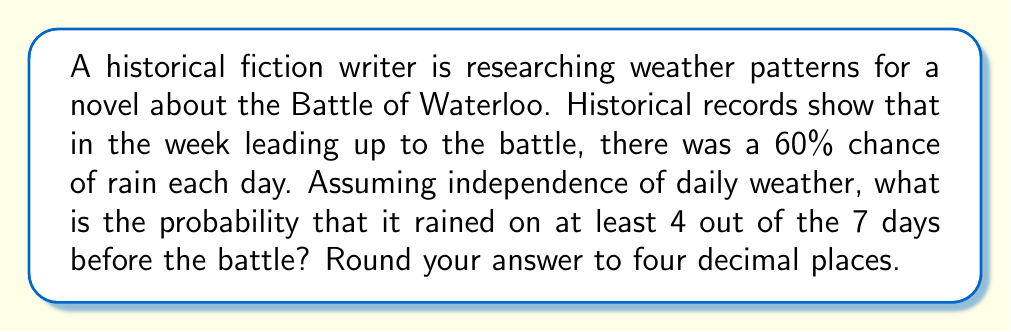What is the answer to this math problem? To solve this problem, we'll use the binomial probability distribution and the complement rule.

Let $X$ be the number of rainy days in the week.
$n = 7$ (number of days)
$p = 0.60$ (probability of rain each day)

We need to find $P(X \geq 4)$, which is equivalent to $1 - P(X \leq 3)$

Using the complement rule:
$P(X \geq 4) = 1 - P(X \leq 3)$

$P(X \leq 3)$ can be calculated as the sum of probabilities for 0, 1, 2, and 3 rainy days:

$P(X \leq 3) = P(X=0) + P(X=1) + P(X=2) + P(X=3)$

The probability for each case can be calculated using the binomial probability formula:

$P(X=k) = \binom{n}{k} p^k (1-p)^{n-k}$

Calculating each term:

$P(X=0) = \binom{7}{0} 0.60^0 (1-0.60)^7 = 0.0016384$

$P(X=1) = \binom{7}{1} 0.60^1 (1-0.60)^6 = 0.0172032$

$P(X=2) = \binom{7}{2} 0.60^2 (1-0.60)^5 = 0.0774144$

$P(X=3) = \binom{7}{3} 0.60^3 (1-0.60)^4 = 0.1936$

Sum these probabilities:
$P(X \leq 3) = 0.0016384 + 0.0172032 + 0.0774144 + 0.1936 = 0.289856$

Now, we can find $P(X \geq 4)$:
$P(X \geq 4) = 1 - P(X \leq 3) = 1 - 0.289856 = 0.710144$

Rounding to four decimal places: 0.7101
Answer: 0.7101 